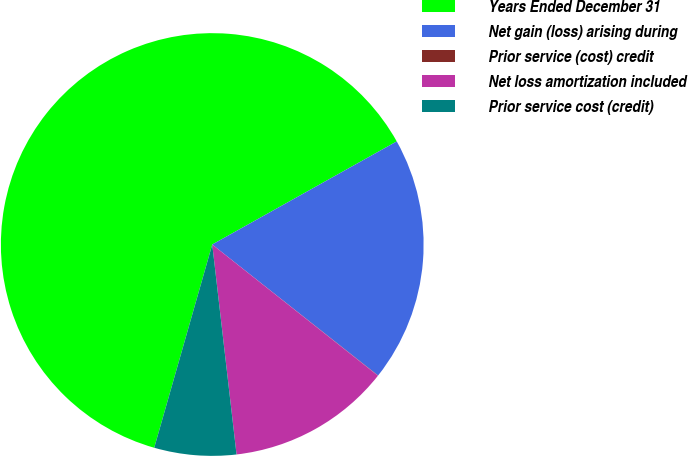<chart> <loc_0><loc_0><loc_500><loc_500><pie_chart><fcel>Years Ended December 31<fcel>Net gain (loss) arising during<fcel>Prior service (cost) credit<fcel>Net loss amortization included<fcel>Prior service cost (credit)<nl><fcel>62.47%<fcel>18.75%<fcel>0.02%<fcel>12.51%<fcel>6.26%<nl></chart> 